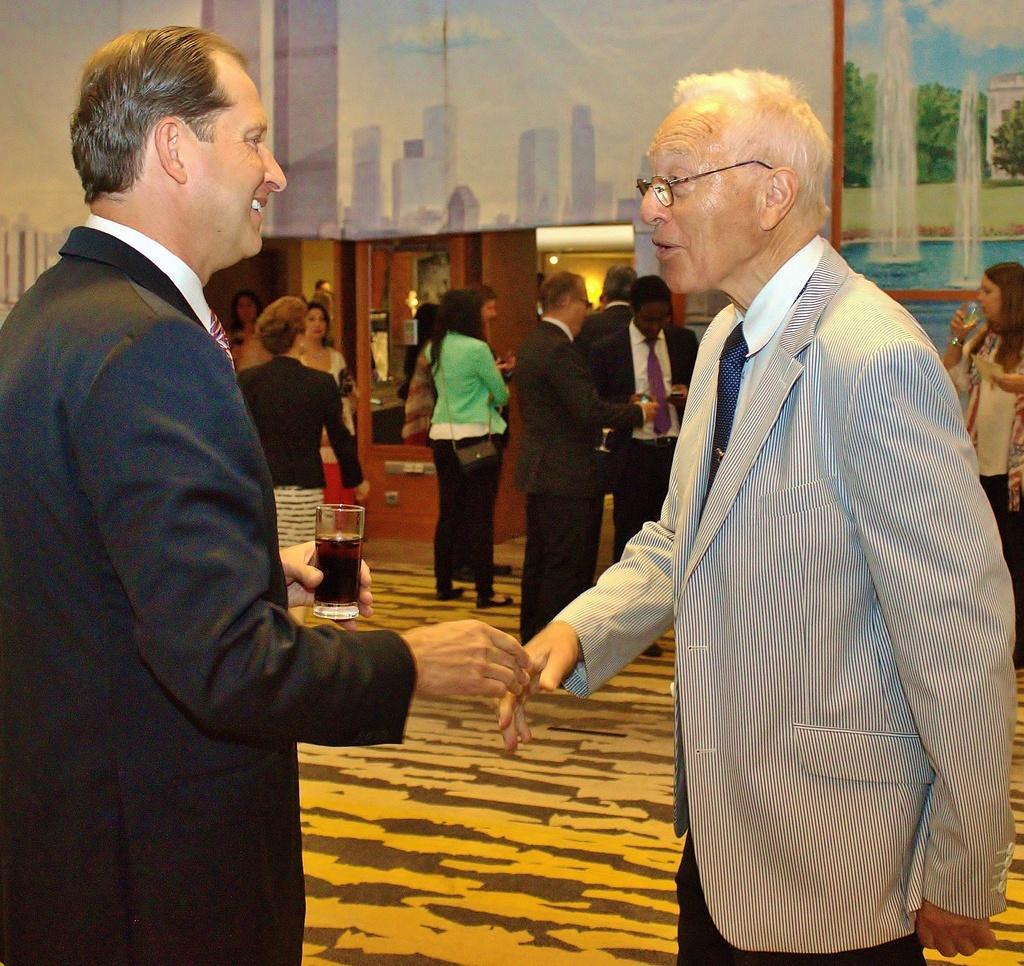How would you summarize this image in a sentence or two? There is a person standing on the left side. He is wearing a coat and he is having a smile on his face. There is a person on the right side. He is also wearing a coat and he is having a conversation with this person. Here we can see a few people who are standing and having a drink. 